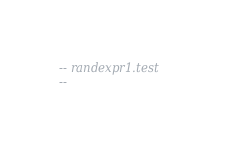Convert code to text. <code><loc_0><loc_0><loc_500><loc_500><_SQL_>-- randexpr1.test
-- </code> 